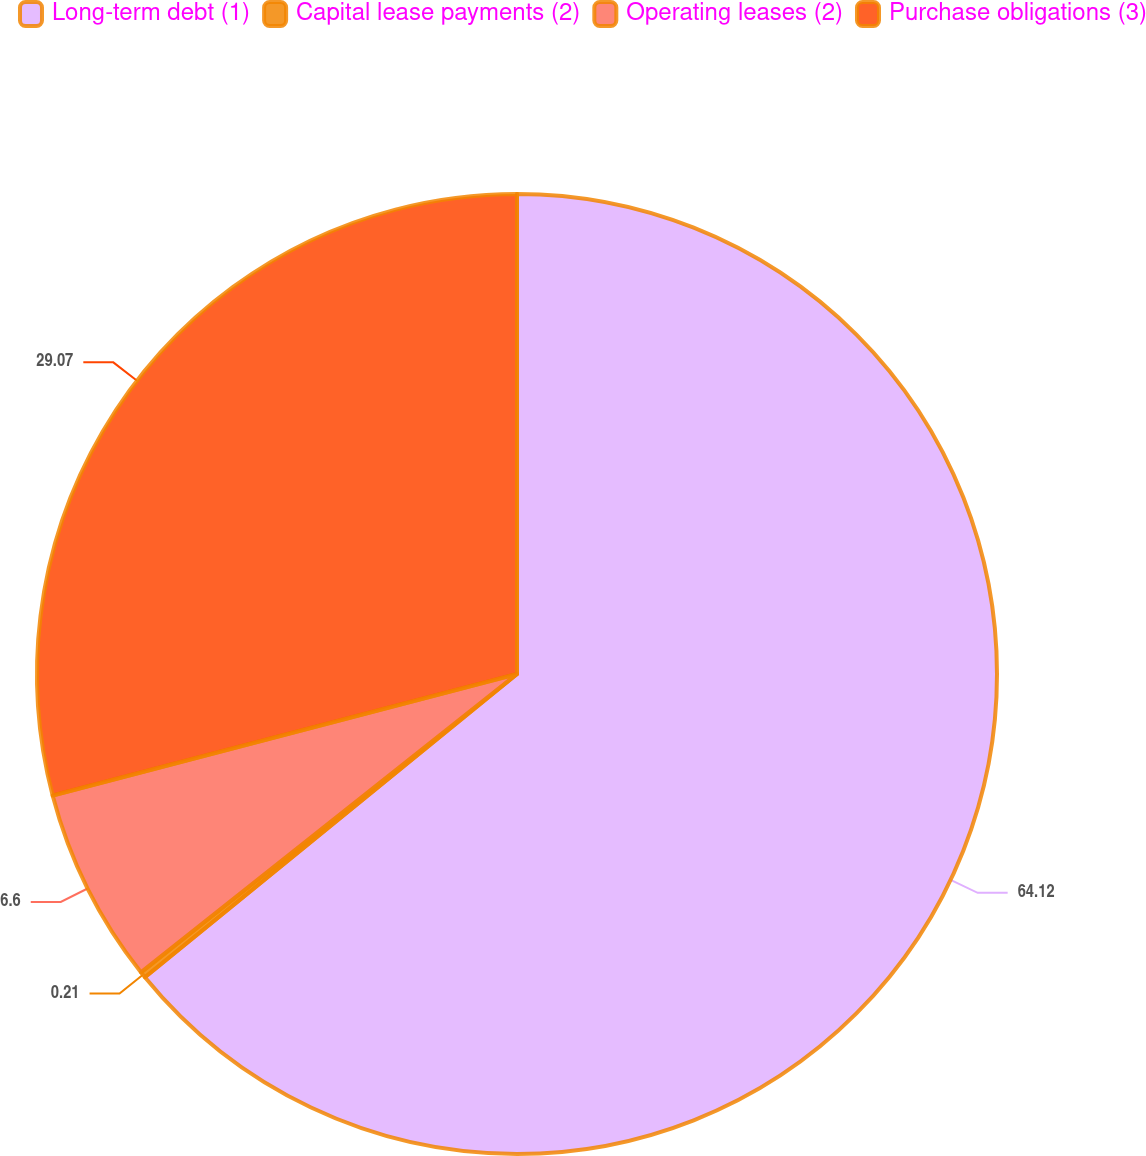Convert chart to OTSL. <chart><loc_0><loc_0><loc_500><loc_500><pie_chart><fcel>Long-term debt (1)<fcel>Capital lease payments (2)<fcel>Operating leases (2)<fcel>Purchase obligations (3)<nl><fcel>64.11%<fcel>0.21%<fcel>6.6%<fcel>29.07%<nl></chart> 